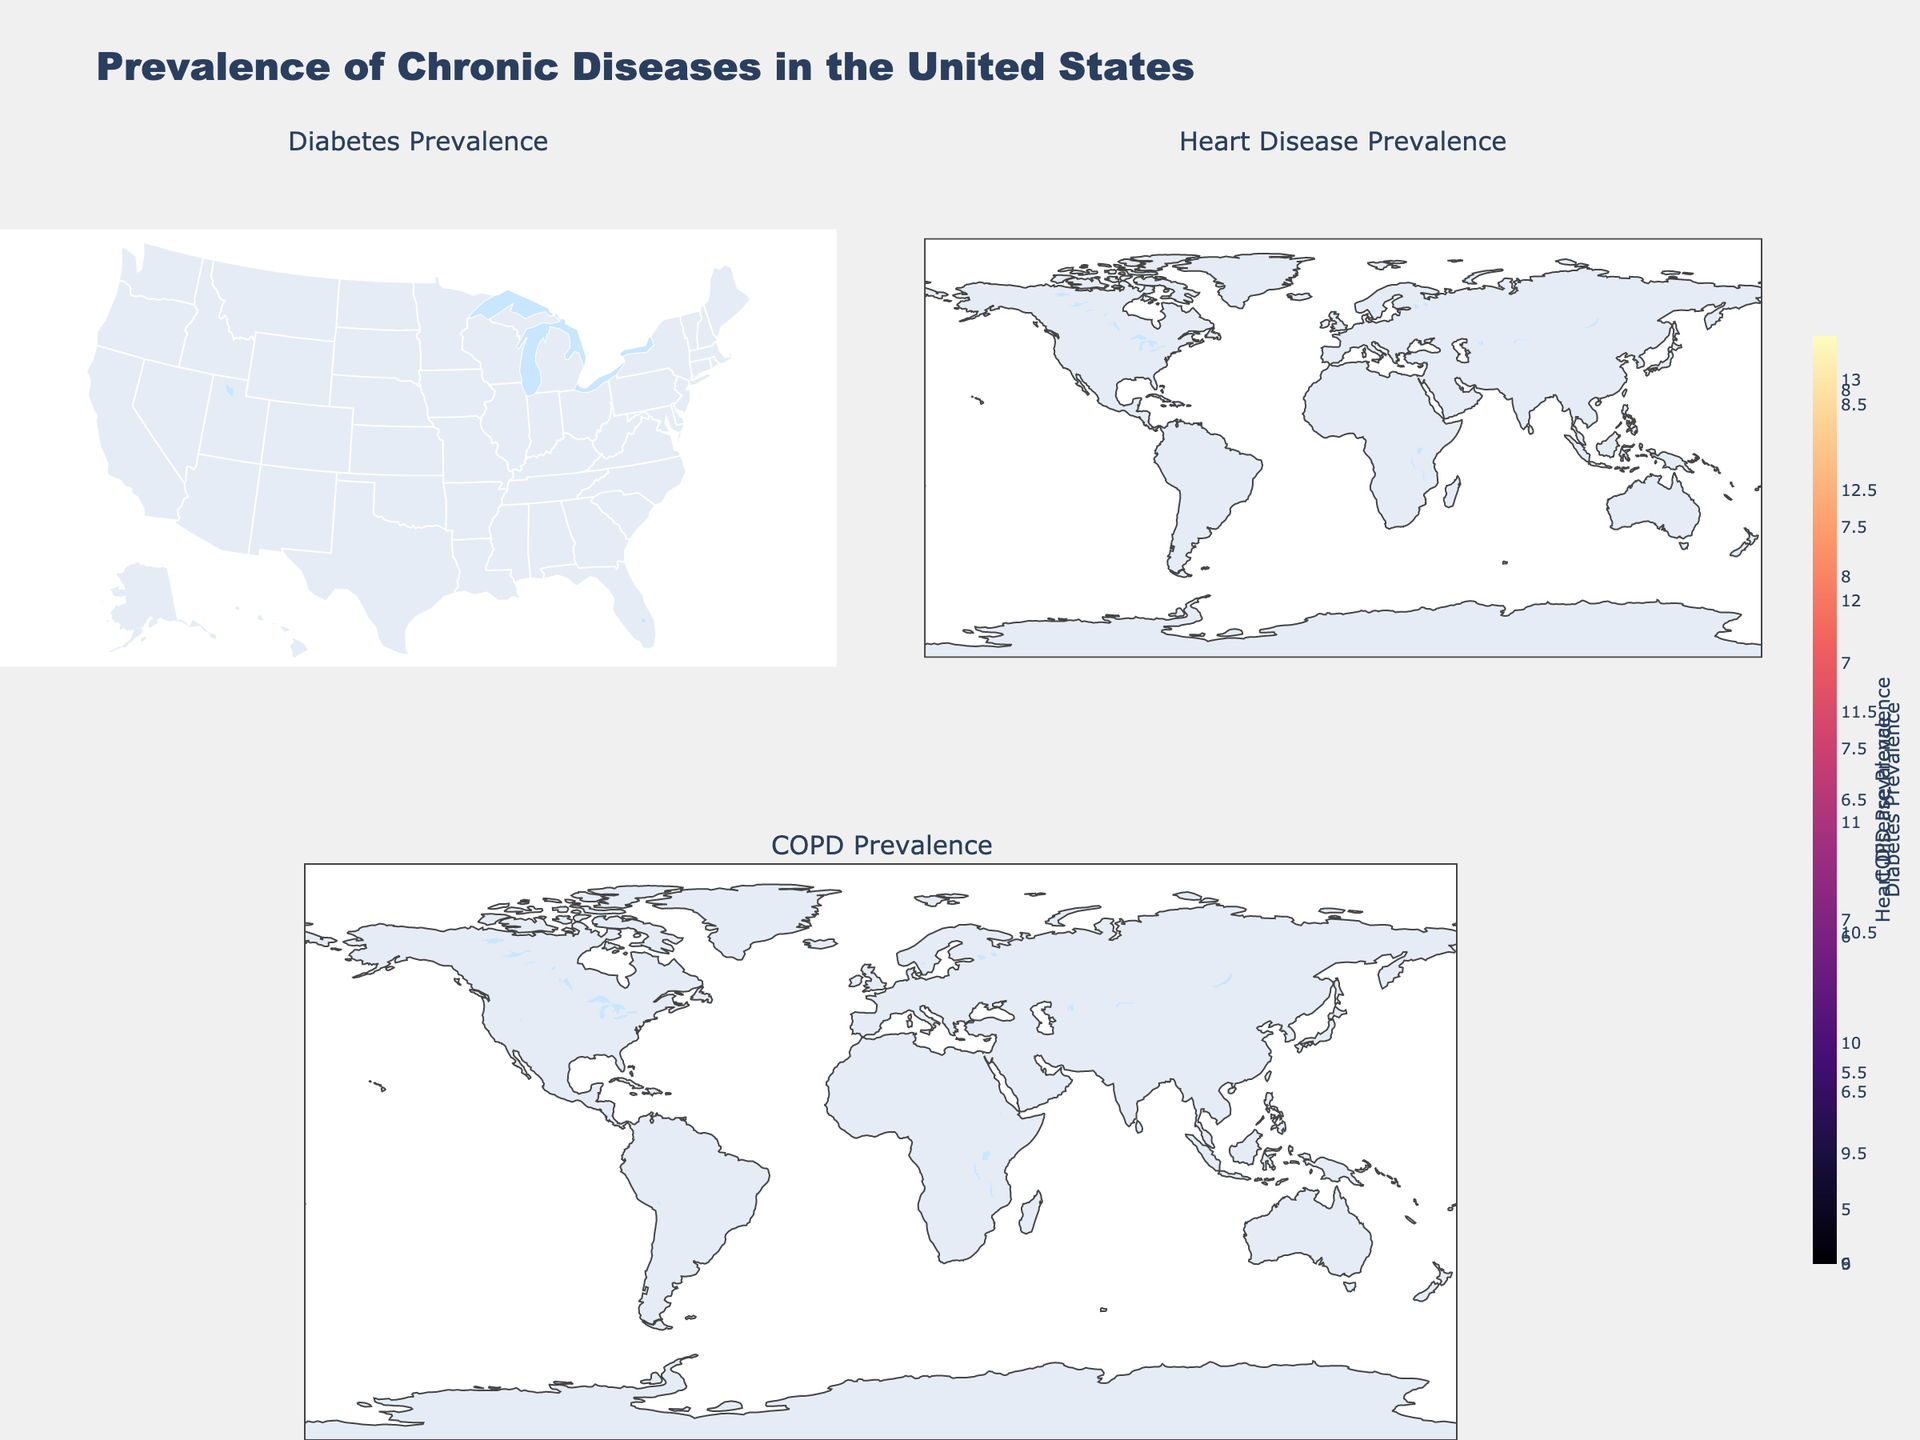Which state has the highest diabetes prevalence? The figure shows a choropleth map indicating diabetes prevalence across different states. By observing the color gradient and disease title, the darkest color in the Diabetes Prevalence map represents Tennessee.
Answer: Tennessee What state shows the lowest prevalence of COPD? The COPD Prevalence map shows varying shades based on the value ranges. The state with the lightest color indicates Massachusetts.
Answer: Massachusetts Between Florida and Ohio, which state has a higher heart disease prevalence? The Heart Disease Prevalence map can be used to compare the colors representing Florida and Ohio. Florida's color is darker, indicating higher prevalence.
Answer: Florida What is the combined prevalence of diabetes and COPD in Indiana? From the Diabetes and COPD Prevalence maps, Indiana has a diabetes prevalence of 12.3% and a COPD prevalence of 7.0%. Adding these together gives the total combined prevalence.
Answer: 19.3% Which has a more significant variation in prevalence among states, Diabetes or Heart Disease? This requires assessing the range of colors in the Diabetes and Heart Disease Prevalence maps. The Heart Disease map shows more color variation, suggesting higher variability.
Answer: Heart Disease Which geographical region appears to have a consistent lower prevalence of these chronic diseases? By looking at maps for all three conditions, states in the northeastern part of the U.S. (e.g., Massachusetts, New York, New Jersey) show consistently lighter colors, representing lower prevalence.
Answer: Northeastern U.S How does the prevalence of COPD in Texas compare to New York? The COPD Prevalence map indicates the colors for Texas and New York. Texas shows a darker shade compared to New York, indicating higher prevalence.
Answer: Texas Does any map show a state where the prevalence is below 9%? Reviewing each map, the Diabetes Prevalence map indicates that Massachusetts shows a prevalence below 9%.
Answer: Yes, Massachusetts What overall trend can be visualized in the southeastern U.S. regarding chronic disease prevalence? Observing the southeastern region on all prevalence maps, the colors generally show darker shades indicating higher prevalence rates for all analyzed chronic diseases.
Answer: Higher prevalence 